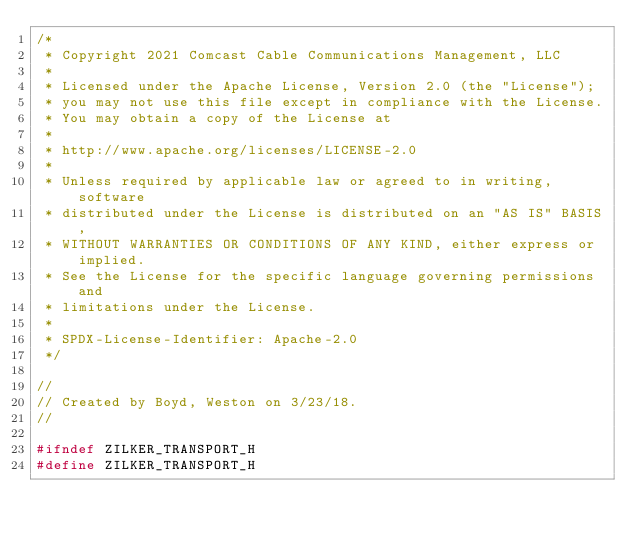<code> <loc_0><loc_0><loc_500><loc_500><_C_>/*
 * Copyright 2021 Comcast Cable Communications Management, LLC
 *
 * Licensed under the Apache License, Version 2.0 (the "License");
 * you may not use this file except in compliance with the License.
 * You may obtain a copy of the License at
 *
 * http://www.apache.org/licenses/LICENSE-2.0
 *
 * Unless required by applicable law or agreed to in writing, software
 * distributed under the License is distributed on an "AS IS" BASIS,
 * WITHOUT WARRANTIES OR CONDITIONS OF ANY KIND, either express or implied.
 * See the License for the specific language governing permissions and
 * limitations under the License.
 *
 * SPDX-License-Identifier: Apache-2.0
 */

//
// Created by Boyd, Weston on 3/23/18.
//

#ifndef ZILKER_TRANSPORT_H
#define ZILKER_TRANSPORT_H
</code> 